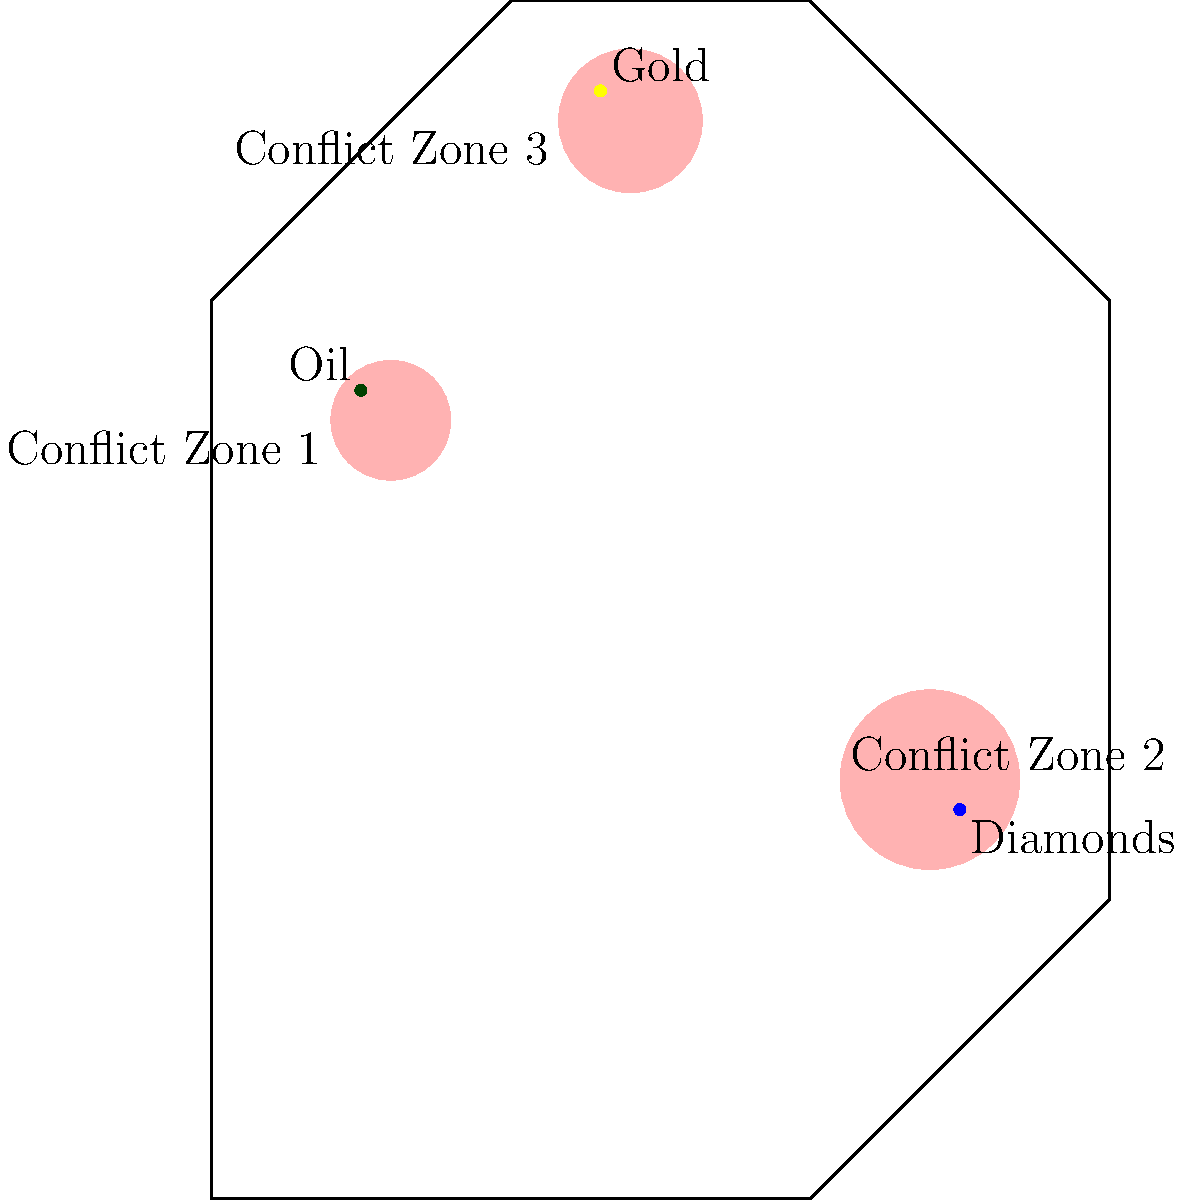Based on the infographic showing the correlation between natural resource locations and conflict zones in Africa, which resource appears to have the strongest association with conflict, and why might this be significant in the context of African military history? 1. Observe the infographic carefully, noting the locations of natural resources and conflict zones.

2. Identify the resources:
   - Oil (dark green dot) in the northwest
   - Diamonds (blue dot) in the east
   - Gold (yellow dot) in the northeast

3. Analyze the proximity of each resource to conflict zones:
   - Oil is directly within Conflict Zone 1
   - Diamonds are within Conflict Zone 2
   - Gold is very close to, but not directly within, Conflict Zone 3

4. Compare the size and overlap of conflict zones with resource locations:
   - Oil has the most direct overlap with a conflict zone
   - Diamonds are also within a conflict zone, but the zone is larger
   - Gold is near a conflict zone, but not directly within it

5. Consider the historical context:
   - Oil has been a major factor in many African conflicts, particularly in countries like Nigeria, Sudan, and Libya
   - The concept of "blood diamonds" has been significant in conflicts in countries like Sierra Leone and Angola
   - Gold has been a factor in some conflicts, but generally to a lesser extent than oil or diamonds

6. Conclude that oil appears to have the strongest association with conflict based on this infographic.

7. Significance in African military history:
   - Oil's strong association with conflict zones reflects its role as a key driver of military and political power struggles in Africa
   - Control over oil resources has often been a central factor in civil wars and international interventions
   - Understanding this connection is crucial for analyzing the motivations behind many African conflicts and their socio-political impacts
Answer: Oil; it's directly within a conflict zone, reflecting its historical role in driving African conflicts and power struggles. 